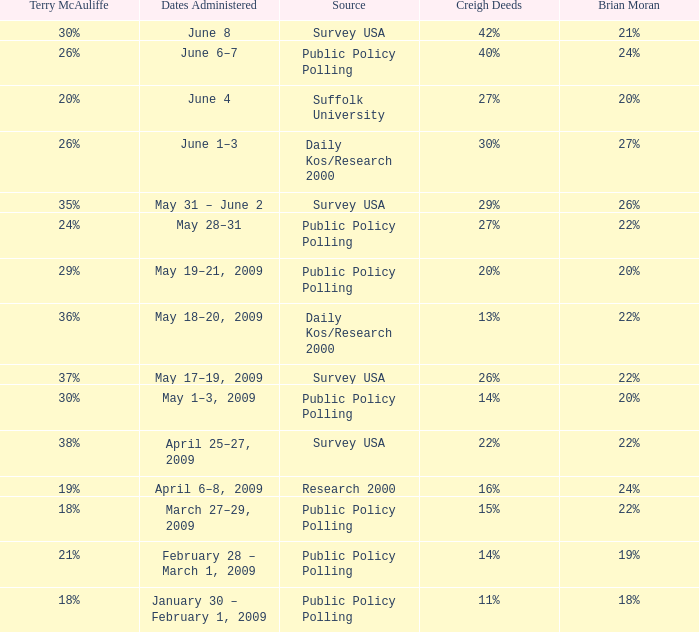Which Terry McAuliffe is it that has a Dates Administered on June 6–7? 26%. Could you help me parse every detail presented in this table? {'header': ['Terry McAuliffe', 'Dates Administered', 'Source', 'Creigh Deeds', 'Brian Moran'], 'rows': [['30%', 'June 8', 'Survey USA', '42%', '21%'], ['26%', 'June 6–7', 'Public Policy Polling', '40%', '24%'], ['20%', 'June 4', 'Suffolk University', '27%', '20%'], ['26%', 'June 1–3', 'Daily Kos/Research 2000', '30%', '27%'], ['35%', 'May 31 – June 2', 'Survey USA', '29%', '26%'], ['24%', 'May 28–31', 'Public Policy Polling', '27%', '22%'], ['29%', 'May 19–21, 2009', 'Public Policy Polling', '20%', '20%'], ['36%', 'May 18–20, 2009', 'Daily Kos/Research 2000', '13%', '22%'], ['37%', 'May 17–19, 2009', 'Survey USA', '26%', '22%'], ['30%', 'May 1–3, 2009', 'Public Policy Polling', '14%', '20%'], ['38%', 'April 25–27, 2009', 'Survey USA', '22%', '22%'], ['19%', 'April 6–8, 2009', 'Research 2000', '16%', '24%'], ['18%', 'March 27–29, 2009', 'Public Policy Polling', '15%', '22%'], ['21%', 'February 28 – March 1, 2009', 'Public Policy Polling', '14%', '19%'], ['18%', 'January 30 – February 1, 2009', 'Public Policy Polling', '11%', '18%']]} 